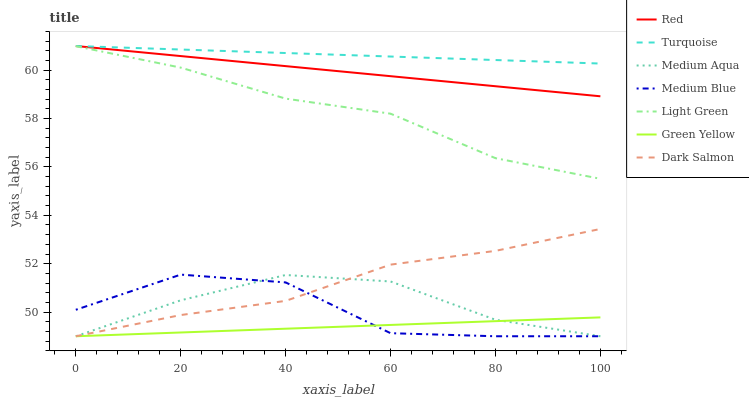Does Green Yellow have the minimum area under the curve?
Answer yes or no. Yes. Does Turquoise have the maximum area under the curve?
Answer yes or no. Yes. Does Medium Blue have the minimum area under the curve?
Answer yes or no. No. Does Medium Blue have the maximum area under the curve?
Answer yes or no. No. Is Green Yellow the smoothest?
Answer yes or no. Yes. Is Medium Blue the roughest?
Answer yes or no. Yes. Is Dark Salmon the smoothest?
Answer yes or no. No. Is Dark Salmon the roughest?
Answer yes or no. No. Does Medium Blue have the lowest value?
Answer yes or no. Yes. Does Light Green have the lowest value?
Answer yes or no. No. Does Red have the highest value?
Answer yes or no. Yes. Does Medium Blue have the highest value?
Answer yes or no. No. Is Medium Blue less than Turquoise?
Answer yes or no. Yes. Is Light Green greater than Medium Aqua?
Answer yes or no. Yes. Does Turquoise intersect Red?
Answer yes or no. Yes. Is Turquoise less than Red?
Answer yes or no. No. Is Turquoise greater than Red?
Answer yes or no. No. Does Medium Blue intersect Turquoise?
Answer yes or no. No. 